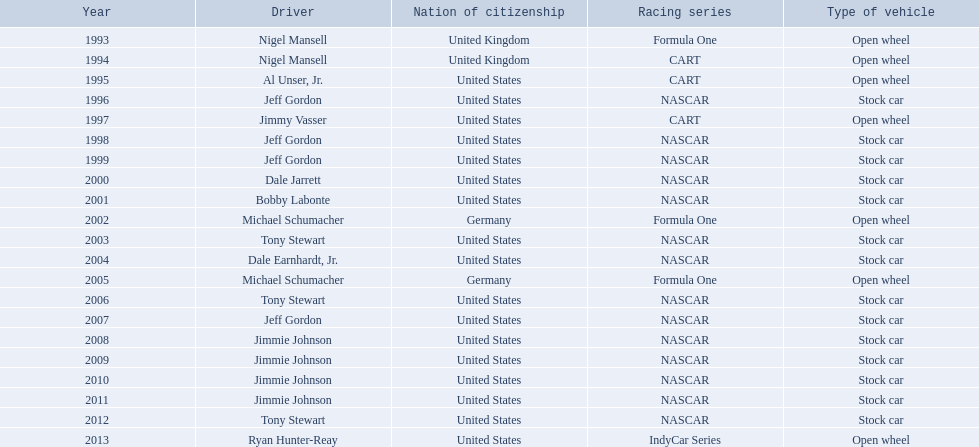In 2004, which of these individuals received an espy award: bobby labonte, tony stewart, dale earnhardt jr., or jeff gordon? Dale Earnhardt, Jr. Additionally, who was the 1997 espy winner: nigel mansell, al unser jr., jeff gordon, or jimmy vasser? Jimmy Vasser. Lastly, who among nigel mansell, al unser jr., michael schumacher, and jeff gordon has just a single espy? Al Unser, Jr. 